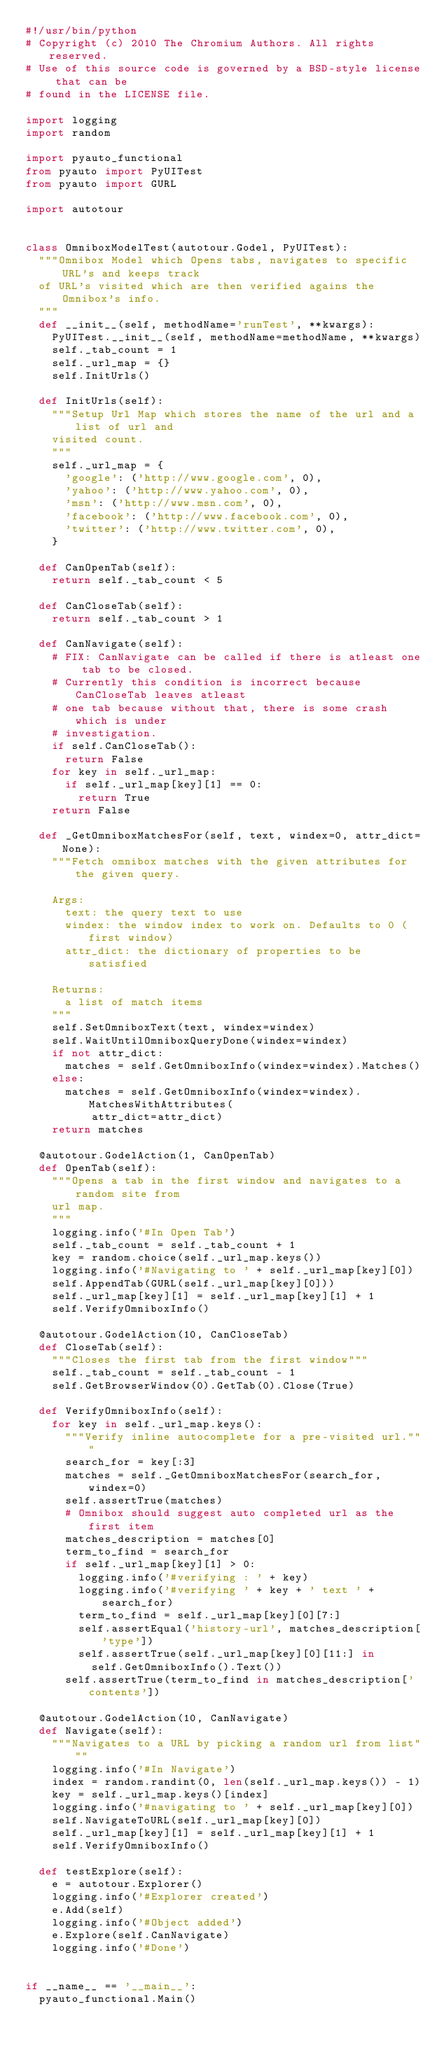<code> <loc_0><loc_0><loc_500><loc_500><_Python_>#!/usr/bin/python
# Copyright (c) 2010 The Chromium Authors. All rights reserved.
# Use of this source code is governed by a BSD-style license that can be
# found in the LICENSE file.

import logging
import random

import pyauto_functional
from pyauto import PyUITest
from pyauto import GURL

import autotour


class OmniboxModelTest(autotour.Godel, PyUITest):
  """Omnibox Model which Opens tabs, navigates to specific URL's and keeps track
  of URL's visited which are then verified agains the Omnibox's info.
  """
  def __init__(self, methodName='runTest', **kwargs):
    PyUITest.__init__(self, methodName=methodName, **kwargs)
    self._tab_count = 1
    self._url_map = {}
    self.InitUrls()

  def InitUrls(self):
    """Setup Url Map which stores the name of the url and a list of url and
    visited count.
    """
    self._url_map = {
      'google': ('http://www.google.com', 0),
      'yahoo': ('http://www.yahoo.com', 0),
      'msn': ('http://www.msn.com', 0),
      'facebook': ('http://www.facebook.com', 0),
      'twitter': ('http://www.twitter.com', 0),
    }

  def CanOpenTab(self):
    return self._tab_count < 5

  def CanCloseTab(self):
    return self._tab_count > 1

  def CanNavigate(self):
    # FIX: CanNavigate can be called if there is atleast one tab to be closed.
    # Currently this condition is incorrect because CanCloseTab leaves atleast
    # one tab because without that, there is some crash which is under
    # investigation.
    if self.CanCloseTab():
      return False
    for key in self._url_map:
      if self._url_map[key][1] == 0:
        return True
    return False

  def _GetOmniboxMatchesFor(self, text, windex=0, attr_dict=None):
    """Fetch omnibox matches with the given attributes for the given query.

    Args:
      text: the query text to use
      windex: the window index to work on. Defaults to 0 (first window)
      attr_dict: the dictionary of properties to be satisfied

    Returns:
      a list of match items
    """
    self.SetOmniboxText(text, windex=windex)
    self.WaitUntilOmniboxQueryDone(windex=windex)
    if not attr_dict:
      matches = self.GetOmniboxInfo(windex=windex).Matches()
    else:
      matches = self.GetOmniboxInfo(windex=windex).MatchesWithAttributes(
          attr_dict=attr_dict)
    return matches

  @autotour.GodelAction(1, CanOpenTab)
  def OpenTab(self):
    """Opens a tab in the first window and navigates to a random site from
    url map.
    """
    logging.info('#In Open Tab')
    self._tab_count = self._tab_count + 1
    key = random.choice(self._url_map.keys())
    logging.info('#Navigating to ' + self._url_map[key][0])
    self.AppendTab(GURL(self._url_map[key][0]))
    self._url_map[key][1] = self._url_map[key][1] + 1
    self.VerifyOmniboxInfo()

  @autotour.GodelAction(10, CanCloseTab)
  def CloseTab(self):
    """Closes the first tab from the first window"""
    self._tab_count = self._tab_count - 1
    self.GetBrowserWindow(0).GetTab(0).Close(True)

  def VerifyOmniboxInfo(self):
    for key in self._url_map.keys():
      """Verify inline autocomplete for a pre-visited url."""
      search_for = key[:3]
      matches = self._GetOmniboxMatchesFor(search_for, windex=0)
      self.assertTrue(matches)
      # Omnibox should suggest auto completed url as the first item
      matches_description = matches[0]
      term_to_find = search_for
      if self._url_map[key][1] > 0:
        logging.info('#verifying : ' + key)
        logging.info('#verifying ' + key + ' text ' + search_for)
        term_to_find = self._url_map[key][0][7:]
        self.assertEqual('history-url', matches_description['type'])
        self.assertTrue(self._url_map[key][0][11:] in
          self.GetOmniboxInfo().Text())
      self.assertTrue(term_to_find in matches_description['contents'])

  @autotour.GodelAction(10, CanNavigate)
  def Navigate(self):
    """Navigates to a URL by picking a random url from list"""
    logging.info('#In Navigate')
    index = random.randint(0, len(self._url_map.keys()) - 1)
    key = self._url_map.keys()[index]
    logging.info('#navigating to ' + self._url_map[key][0])
    self.NavigateToURL(self._url_map[key][0])
    self._url_map[key][1] = self._url_map[key][1] + 1
    self.VerifyOmniboxInfo()

  def testExplore(self):
    e = autotour.Explorer()
    logging.info('#Explorer created')
    e.Add(self)
    logging.info('#Object added')
    e.Explore(self.CanNavigate)
    logging.info('#Done')


if __name__ == '__main__':
  pyauto_functional.Main()

</code> 